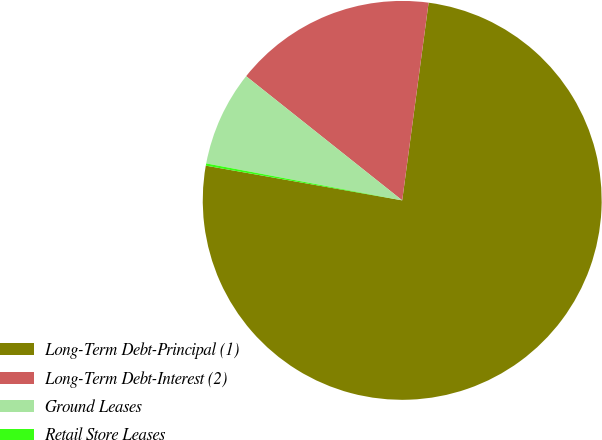<chart> <loc_0><loc_0><loc_500><loc_500><pie_chart><fcel>Long-Term Debt-Principal (1)<fcel>Long-Term Debt-Interest (2)<fcel>Ground Leases<fcel>Retail Store Leases<nl><fcel>75.68%<fcel>16.42%<fcel>7.73%<fcel>0.18%<nl></chart> 